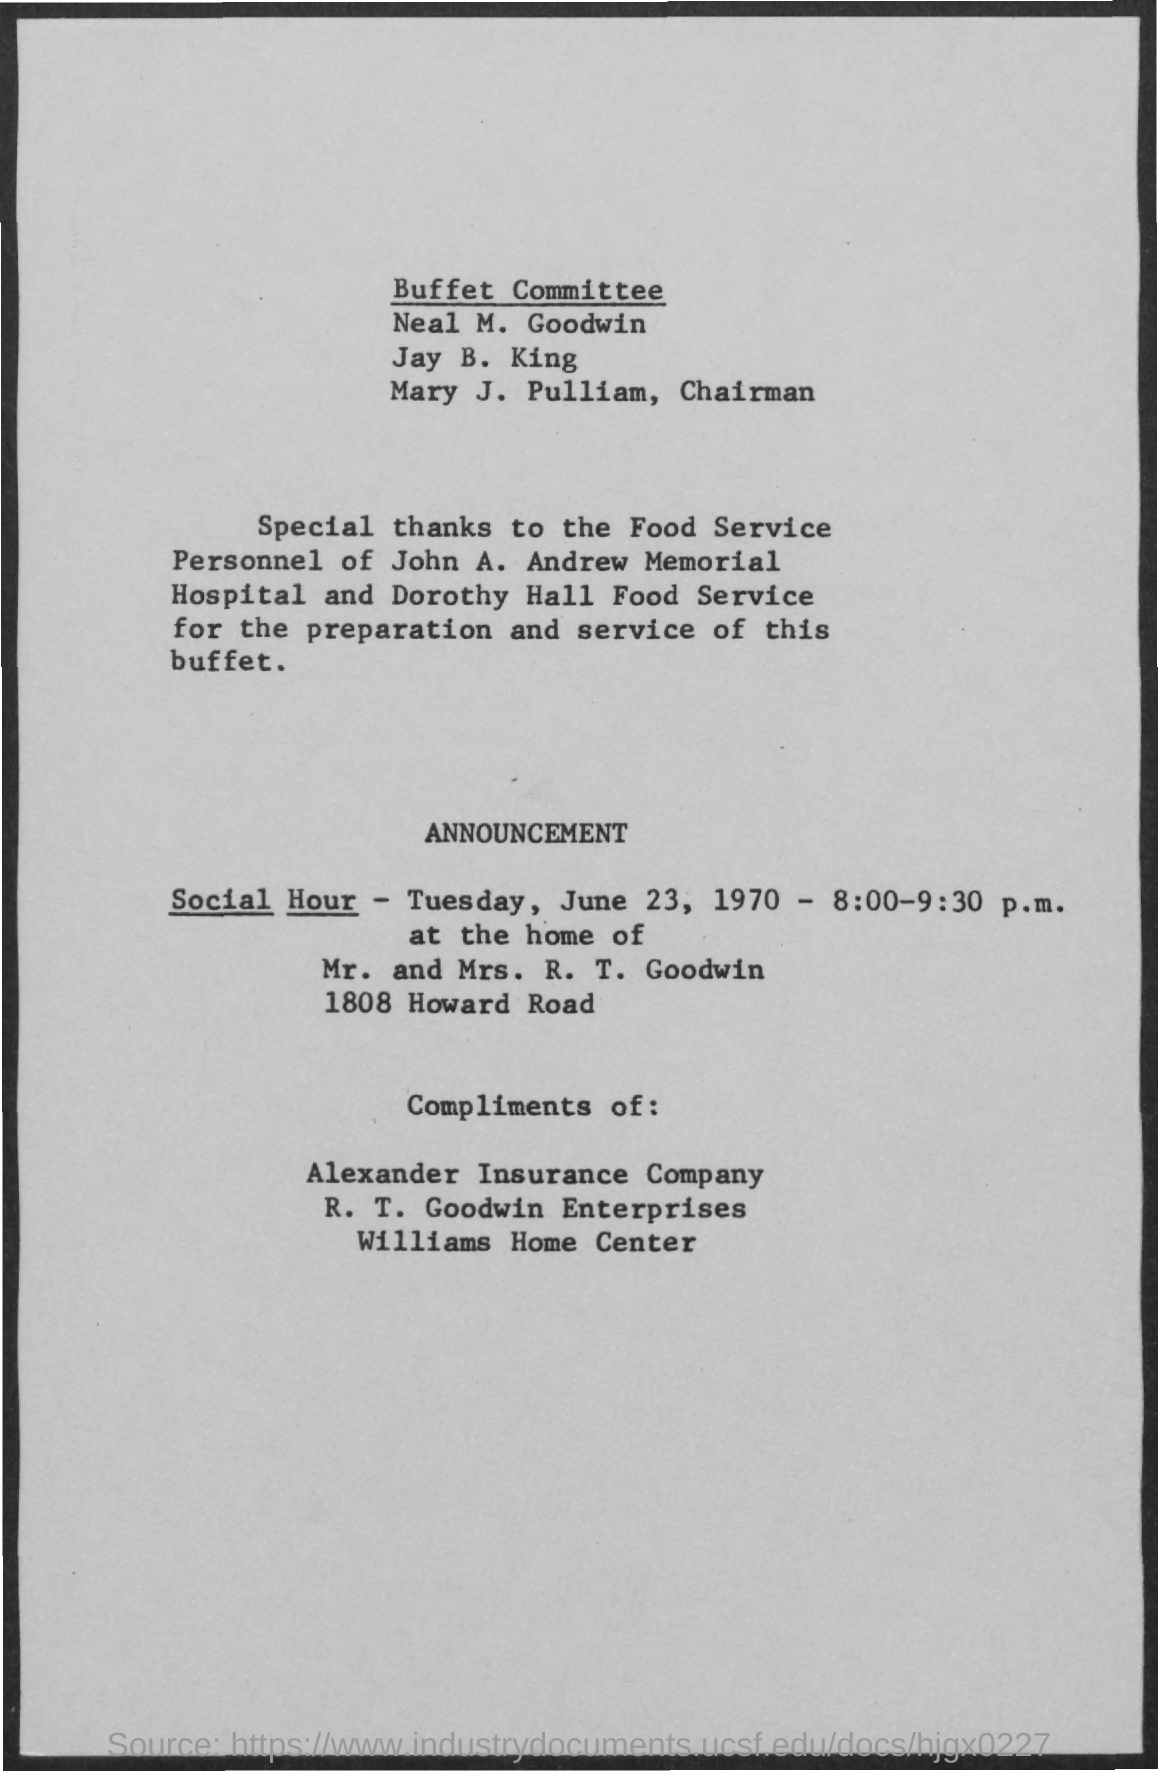Mention the name of first "Buffet Committee" member given?
Offer a terse response. Neal M. Goodwin. Who is the CHAIRMAN of Buffet Committee?
Provide a short and direct response. MARY J. PULLIAM. Provide the "Social Hour" mentioned in the Announcement?
Ensure brevity in your answer.  TUESDAY, JUNE 23, 1970 - 8:00-9:30 P.M. Where is "home of Mr. and Mrs. R. T. Goodwin" located?
Make the answer very short. 1808 Howard Road. Mention the first company name under "Compliments of:" ?
Offer a terse response. Alexander Insurance Company. Mention the "home center" name under "Compliments of:" ?
Your answer should be very brief. Williams Home Center. At what time is "Social Hour" announced?
Keep it short and to the point. 8:00-9:30 P.M. 